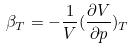Convert formula to latex. <formula><loc_0><loc_0><loc_500><loc_500>\beta _ { T } = - \frac { 1 } { V } ( \frac { \partial V } { \partial p } ) _ { T }</formula> 